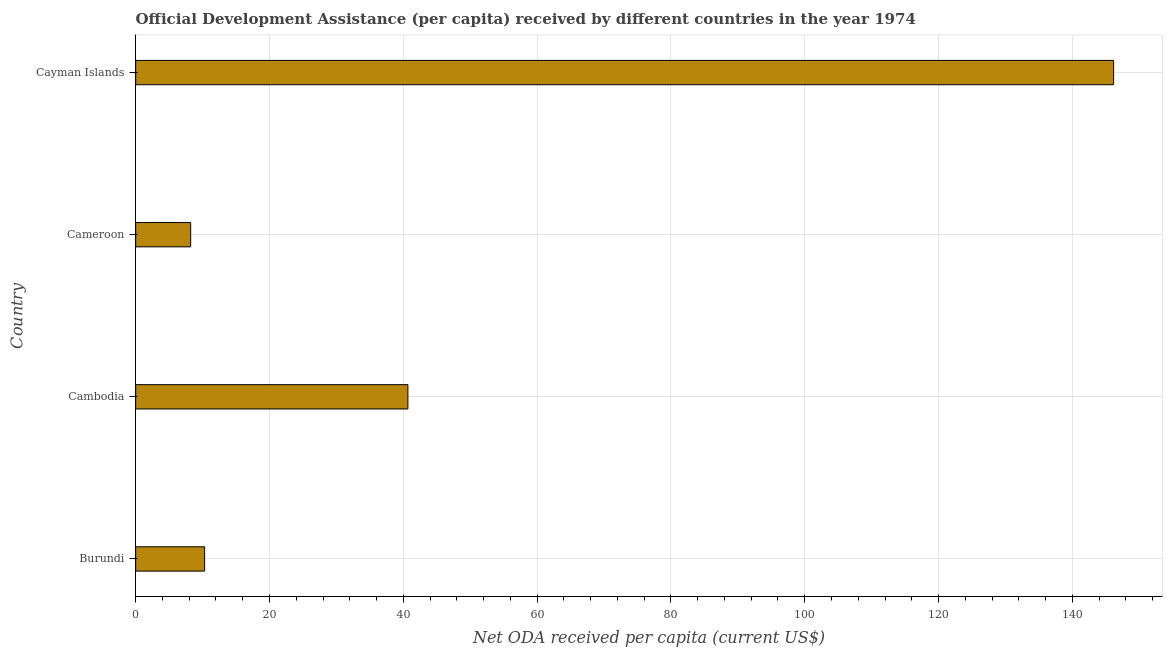Does the graph contain grids?
Your response must be concise. Yes. What is the title of the graph?
Provide a short and direct response. Official Development Assistance (per capita) received by different countries in the year 1974. What is the label or title of the X-axis?
Offer a terse response. Net ODA received per capita (current US$). What is the label or title of the Y-axis?
Your answer should be very brief. Country. What is the net oda received per capita in Cameroon?
Offer a terse response. 8.22. Across all countries, what is the maximum net oda received per capita?
Your answer should be very brief. 146.16. Across all countries, what is the minimum net oda received per capita?
Your answer should be compact. 8.22. In which country was the net oda received per capita maximum?
Make the answer very short. Cayman Islands. In which country was the net oda received per capita minimum?
Your answer should be compact. Cameroon. What is the sum of the net oda received per capita?
Ensure brevity in your answer.  205.38. What is the difference between the net oda received per capita in Burundi and Cambodia?
Offer a very short reply. -30.38. What is the average net oda received per capita per country?
Your response must be concise. 51.34. What is the median net oda received per capita?
Your answer should be compact. 25.5. What is the ratio of the net oda received per capita in Burundi to that in Cambodia?
Make the answer very short. 0.25. Is the net oda received per capita in Burundi less than that in Cambodia?
Your response must be concise. Yes. Is the difference between the net oda received per capita in Cameroon and Cayman Islands greater than the difference between any two countries?
Offer a terse response. Yes. What is the difference between the highest and the second highest net oda received per capita?
Keep it short and to the point. 105.47. What is the difference between the highest and the lowest net oda received per capita?
Give a very brief answer. 137.94. How many bars are there?
Your answer should be compact. 4. Are the values on the major ticks of X-axis written in scientific E-notation?
Offer a terse response. No. What is the Net ODA received per capita (current US$) of Burundi?
Give a very brief answer. 10.31. What is the Net ODA received per capita (current US$) of Cambodia?
Make the answer very short. 40.69. What is the Net ODA received per capita (current US$) of Cameroon?
Make the answer very short. 8.22. What is the Net ODA received per capita (current US$) of Cayman Islands?
Your response must be concise. 146.16. What is the difference between the Net ODA received per capita (current US$) in Burundi and Cambodia?
Give a very brief answer. -30.38. What is the difference between the Net ODA received per capita (current US$) in Burundi and Cameroon?
Provide a succinct answer. 2.09. What is the difference between the Net ODA received per capita (current US$) in Burundi and Cayman Islands?
Keep it short and to the point. -135.86. What is the difference between the Net ODA received per capita (current US$) in Cambodia and Cameroon?
Offer a terse response. 32.47. What is the difference between the Net ODA received per capita (current US$) in Cambodia and Cayman Islands?
Your response must be concise. -105.47. What is the difference between the Net ODA received per capita (current US$) in Cameroon and Cayman Islands?
Provide a short and direct response. -137.94. What is the ratio of the Net ODA received per capita (current US$) in Burundi to that in Cambodia?
Offer a terse response. 0.25. What is the ratio of the Net ODA received per capita (current US$) in Burundi to that in Cameroon?
Your answer should be very brief. 1.25. What is the ratio of the Net ODA received per capita (current US$) in Burundi to that in Cayman Islands?
Provide a short and direct response. 0.07. What is the ratio of the Net ODA received per capita (current US$) in Cambodia to that in Cameroon?
Your answer should be compact. 4.95. What is the ratio of the Net ODA received per capita (current US$) in Cambodia to that in Cayman Islands?
Give a very brief answer. 0.28. What is the ratio of the Net ODA received per capita (current US$) in Cameroon to that in Cayman Islands?
Provide a succinct answer. 0.06. 